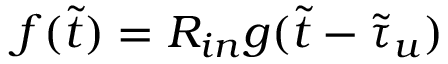Convert formula to latex. <formula><loc_0><loc_0><loc_500><loc_500>f ( \tilde { t } ) = R _ { i n } g ( \tilde { t } - \tilde { \tau } _ { u } )</formula> 